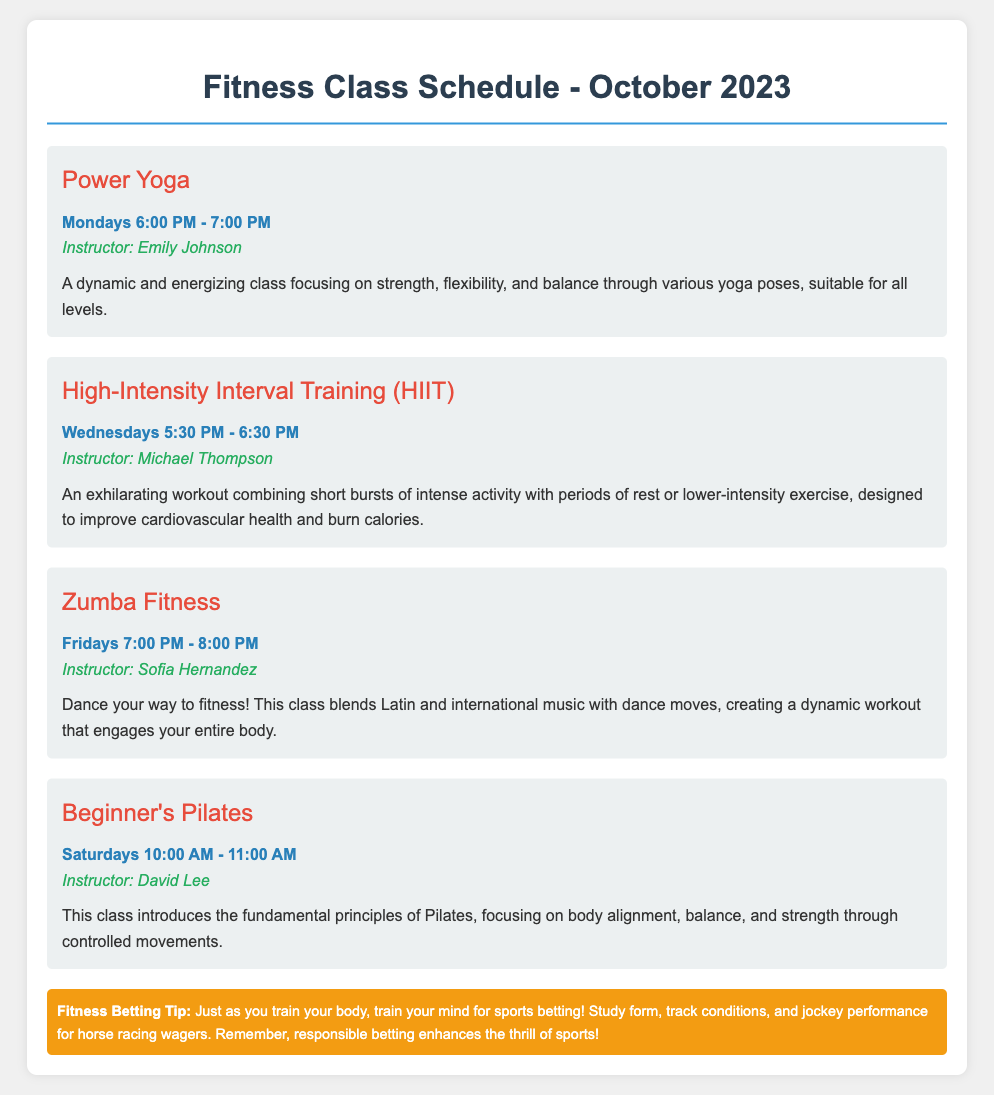What is the name of the yoga class? The document specifies that the yoga class is called Power Yoga.
Answer: Power Yoga Who teaches the HIIT class? The instructor for the HIIT class is mentioned as Michael Thompson.
Answer: Michael Thompson What day and time is Zumba Fitness scheduled? The schedule indicates that Zumba Fitness is on Fridays from 7:00 PM to 8:00 PM.
Answer: Fridays 7:00 PM - 8:00 PM How long is the Beginner's Pilates class? The document states that the Beginner's Pilates class lasts for 1 hour.
Answer: 1 hour What type of music is used in the Zumba Fitness class? The Zumba Fitness class blends Latin and international music for its workouts.
Answer: Latin and international music What is a focus of the Power Yoga class? The description mentions that Power Yoga focuses on strength, flexibility, and balance.
Answer: Strength, flexibility, and balance Which class is aimed at beginners? The document indicates that the class aimed at beginners is Beginner's Pilates.
Answer: Beginner's Pilates What is the fitness betting tip about? The tip discusses studying form, track conditions, and jockey performance for successful sports betting.
Answer: Studying form, track conditions, and jockey performance On which day is the HIIT class offered? The HIIT class is offered on Wednesdays.
Answer: Wednesdays 